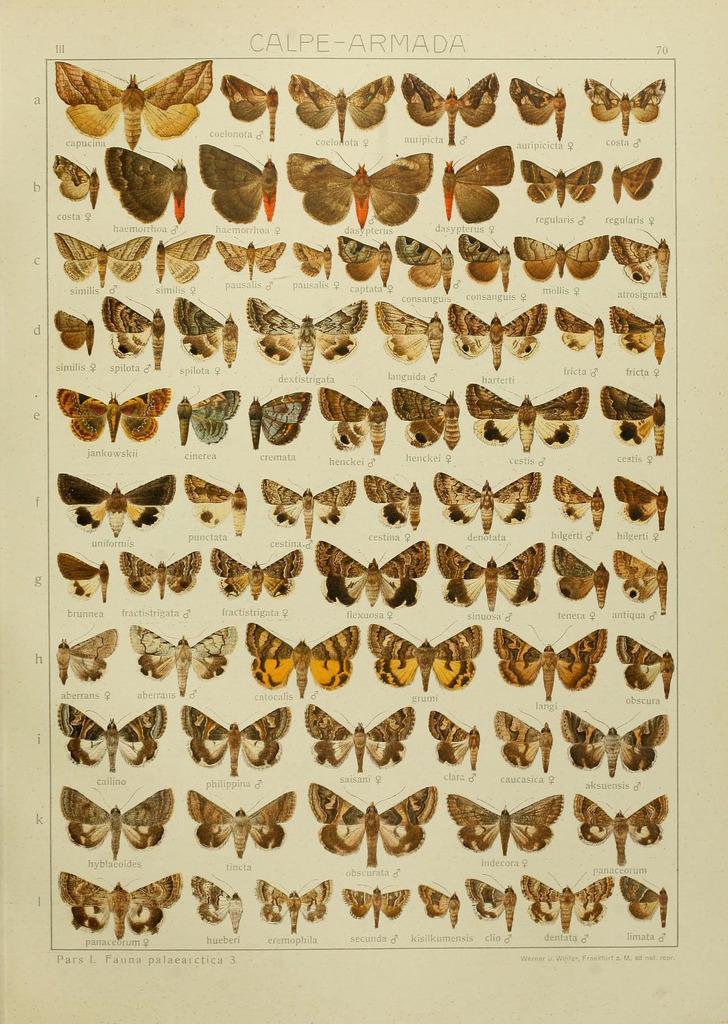Could you give a brief overview of what you see in this image? This image consists of a poster in which there are many butterflies. 